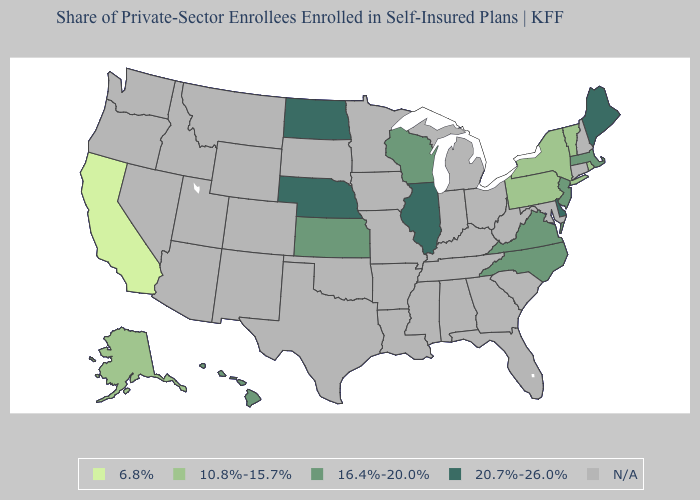Does North Carolina have the highest value in the South?
Answer briefly. No. What is the value of Virginia?
Short answer required. 16.4%-20.0%. What is the value of Mississippi?
Write a very short answer. N/A. What is the highest value in the USA?
Be succinct. 20.7%-26.0%. Which states have the highest value in the USA?
Keep it brief. Delaware, Illinois, Maine, Nebraska, North Dakota. How many symbols are there in the legend?
Short answer required. 5. Name the states that have a value in the range 20.7%-26.0%?
Quick response, please. Delaware, Illinois, Maine, Nebraska, North Dakota. Does Delaware have the highest value in the USA?
Answer briefly. Yes. Name the states that have a value in the range 20.7%-26.0%?
Short answer required. Delaware, Illinois, Maine, Nebraska, North Dakota. Which states have the highest value in the USA?
Quick response, please. Delaware, Illinois, Maine, Nebraska, North Dakota. What is the value of Maine?
Concise answer only. 20.7%-26.0%. Name the states that have a value in the range 20.7%-26.0%?
Keep it brief. Delaware, Illinois, Maine, Nebraska, North Dakota. Which states have the lowest value in the Northeast?
Quick response, please. New York, Pennsylvania, Rhode Island, Vermont. 